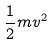<formula> <loc_0><loc_0><loc_500><loc_500>\frac { 1 } { 2 } m v ^ { 2 }</formula> 